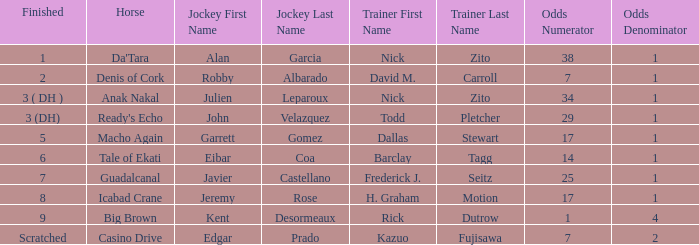What are the Odds for the Horse called Ready's Echo? 29-1. 